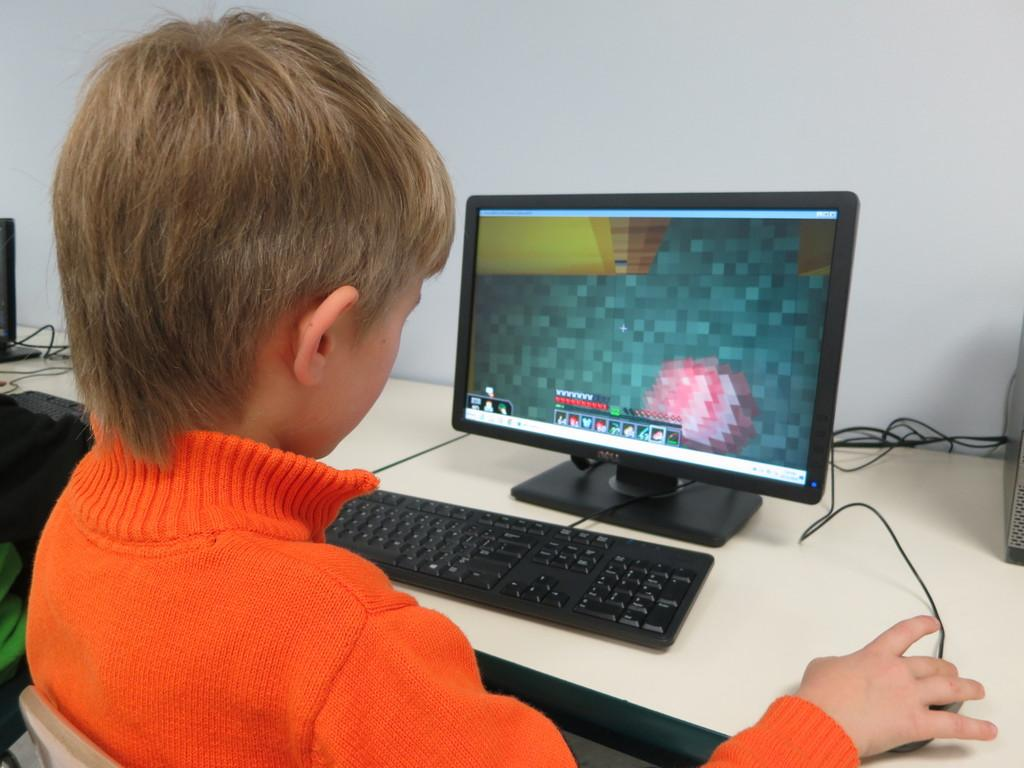<image>
Create a compact narrative representing the image presented. A child playing a video game on a dell computer. 